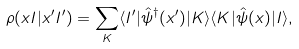Convert formula to latex. <formula><loc_0><loc_0><loc_500><loc_500>\rho ( { x } I | { x ^ { \prime } } I ^ { \prime } ) = \sum _ { K } \langle I ^ { \prime } | \hat { \psi } ^ { \dag } ( { x ^ { \prime } } ) | K \rangle \langle K | \hat { \psi } ( { x } ) | I \rangle ,</formula> 